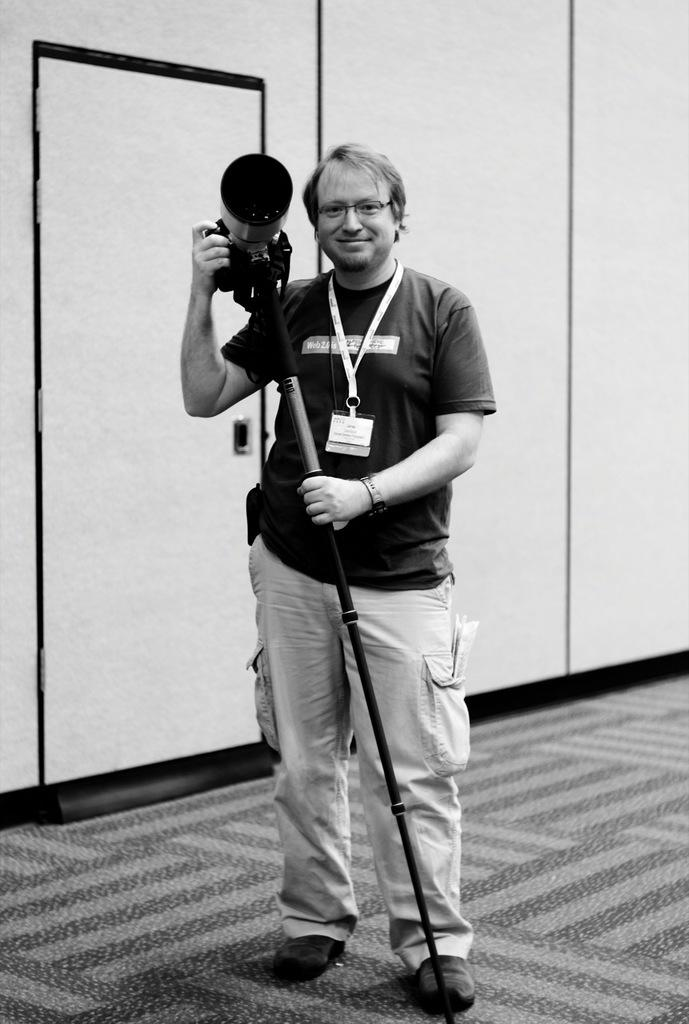What is the main subject of the picture? The main subject of the picture is a man. Can you describe the man's appearance? The man is wearing spectacles and shoes. What is the man holding in the picture? The man is holding a camera and a stick. What can be seen in the background of the picture? There is a door and a wall visible in the background of the picture. What type of vessel is floating in the background of the image? There is no vessel present in the background of the image. How many bubbles can be seen around the man in the image? There are no bubbles visible around the man in the image. 